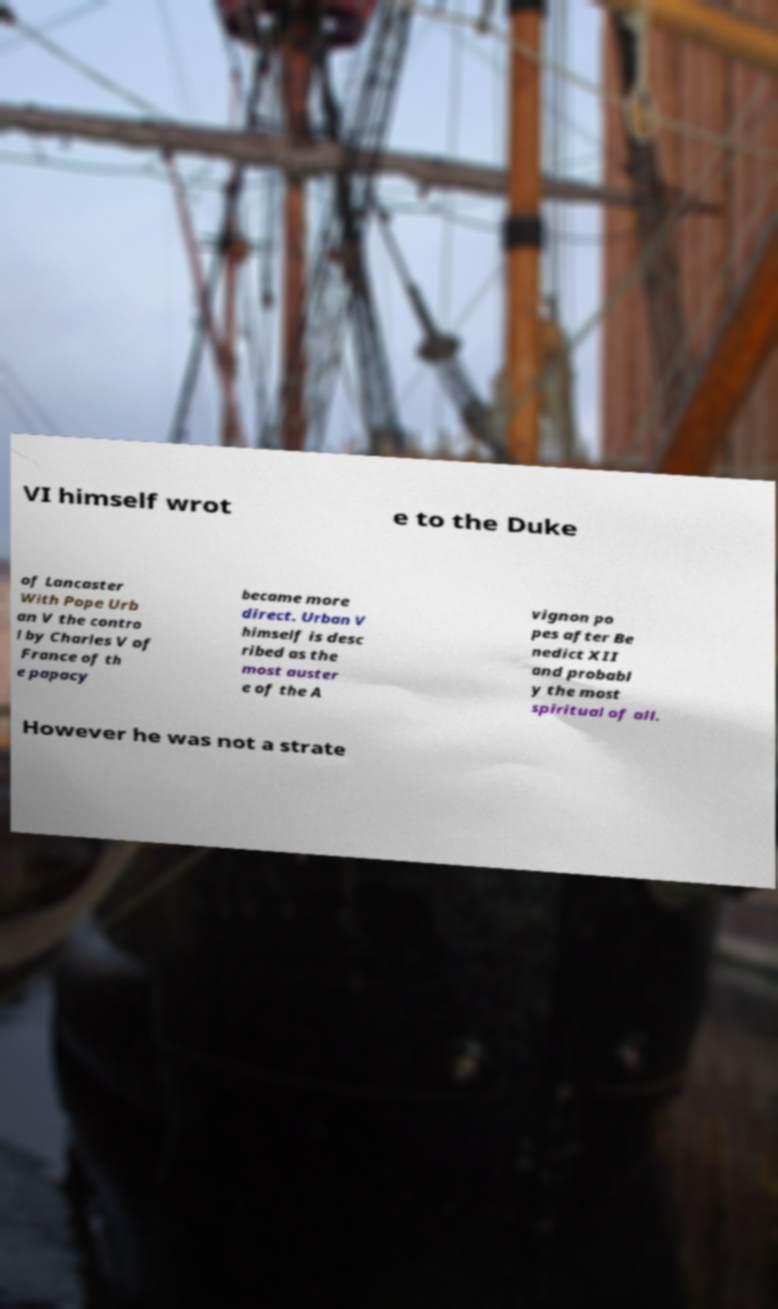Please read and relay the text visible in this image. What does it say? VI himself wrot e to the Duke of Lancaster With Pope Urb an V the contro l by Charles V of France of th e papacy became more direct. Urban V himself is desc ribed as the most auster e of the A vignon po pes after Be nedict XII and probabl y the most spiritual of all. However he was not a strate 